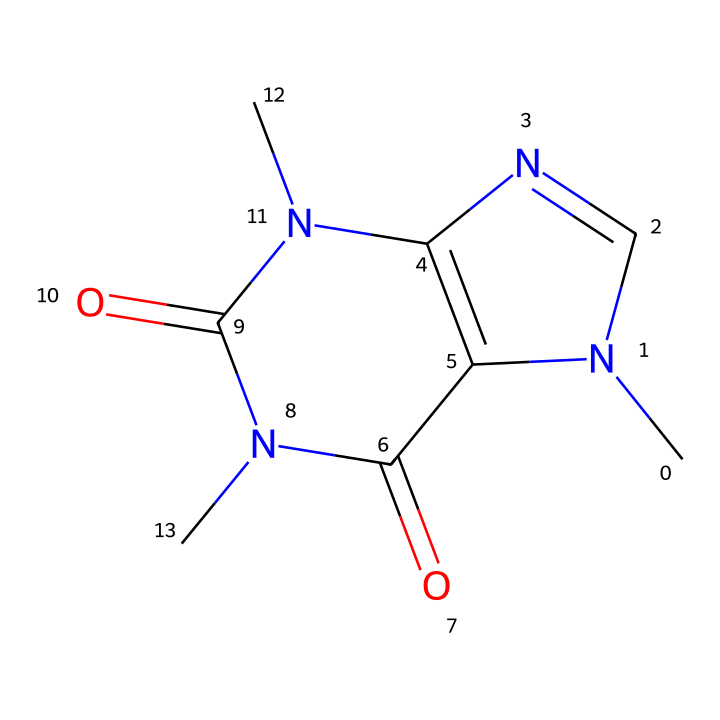What is the total number of nitrogen atoms in the caffeine structure? By examining the SMILES representation, we identify the nitrogen (N) atoms present in the structure. There are three instances of nitrogen in the SMILES, indicating a total of three nitrogen atoms in caffeine.
Answer: three How many rings are present in the caffeine structure? The SMILES indicates multiple cyclic components in the molecule. By breaking down the SMILES, we can see there are two fused rings involved, which accounts for a total of two rings in the structure of caffeine.
Answer: two What type of isomers can caffeine exhibit due to its double bonds? Caffeine contains double bonds in its structure, making it a candidate for geometric isomerism, specifically cis and trans isomerism regarding the arrangement around the double bonds.
Answer: cis and trans What functional groups are present in caffeine? From the structure, we observe the presence of amine groups (-NH) and carbonyl groups (C=O) within the rings. This indicates the presence of amides and a nitrogenous base characteristic of caffeine.
Answer: amides, nitrogenous base Do the geometric isomers of caffeine differ in effects on alertness? Geometric isomers can have different spatial arrangements, and while the base structure of caffeine is consistent, research suggests that geometric isomers may influence pharmacological effects, thus potentially varying in alertness or stimulation levels.
Answer: yes 